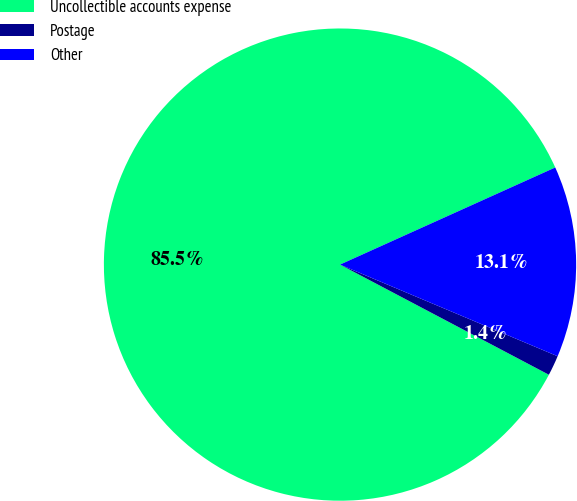Convert chart. <chart><loc_0><loc_0><loc_500><loc_500><pie_chart><fcel>Uncollectible accounts expense<fcel>Postage<fcel>Other<nl><fcel>85.53%<fcel>1.38%<fcel>13.09%<nl></chart> 